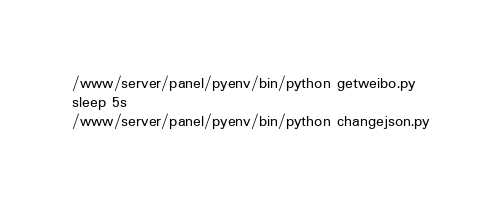Convert code to text. <code><loc_0><loc_0><loc_500><loc_500><_Bash_>/www/server/panel/pyenv/bin/python getweibo.py
sleep 5s
/www/server/panel/pyenv/bin/python changejson.py</code> 